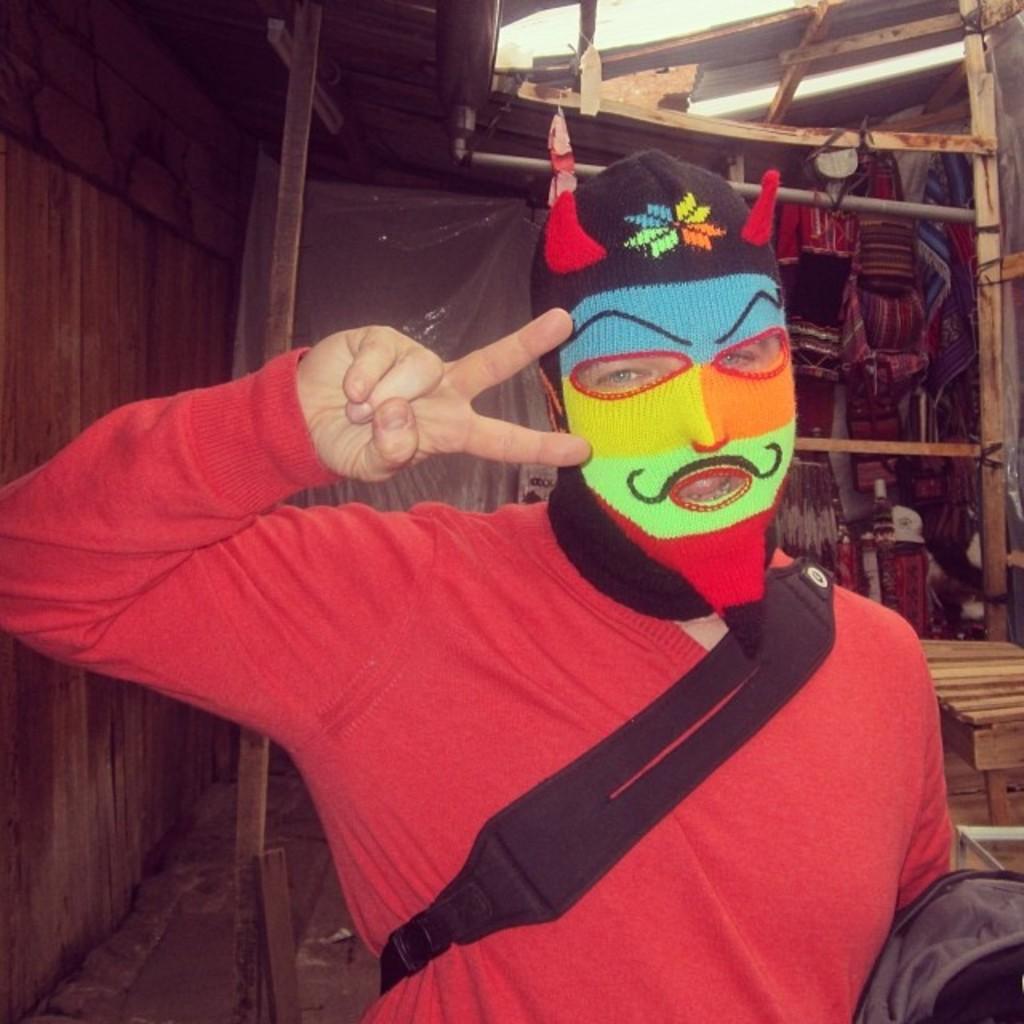Please provide a concise description of this image. In the center of the image we can see person standing. In the background we can see wall and wooden sticks. 